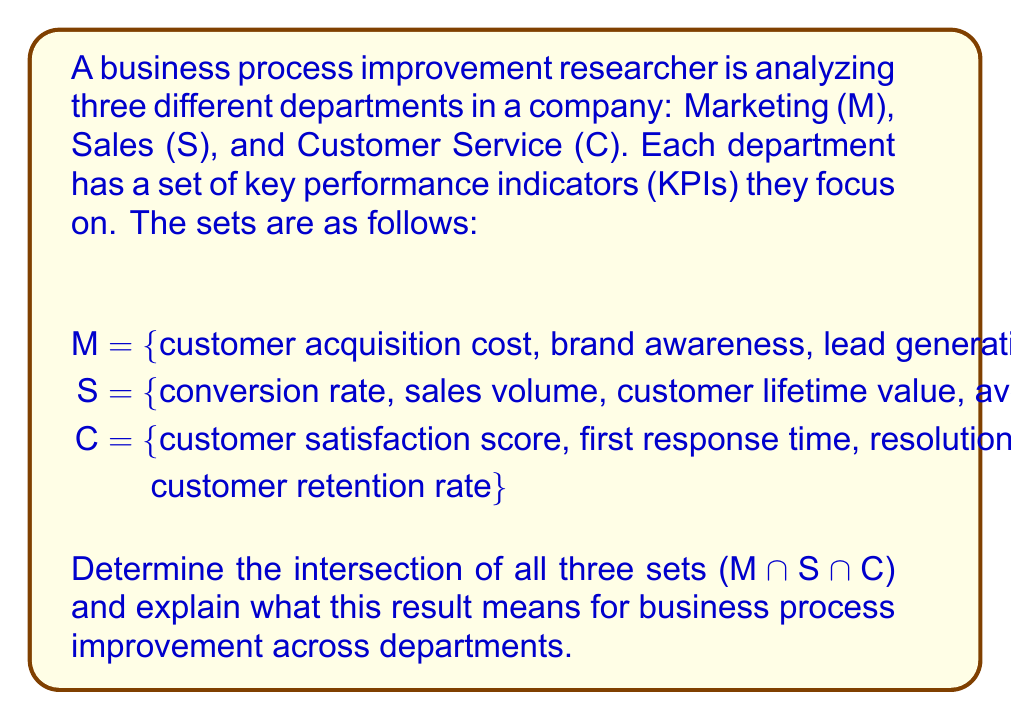Show me your answer to this math problem. To solve this problem, we need to identify the elements that are common to all three sets. Let's approach this step-by-step:

1. First, let's examine the elements in each set:
   M = {customer acquisition cost, brand awareness, lead generation, conversion rate}
   S = {conversion rate, sales volume, customer lifetime value, average deal size}
   C = {customer satisfaction score, first response time, resolution time, customer retention rate}

2. To find the intersection of all three sets, we need to identify elements that appear in all sets simultaneously.

3. Comparing the sets:
   - The only element that appears in more than one set is "conversion rate", which is present in both M and S.
   - However, "conversion rate" does not appear in set C.

4. Therefore, there are no elements that are common to all three sets.

5. Mathematically, we can express this as:
   $$ M ∩ S ∩ C = ∅ $$
   Where ∅ represents the empty set.

6. In terms of business process improvement, this result indicates that there are no KPIs that are currently shared across all three departments. This insight suggests several potential areas for improvement:

   a) The departments may be working in silos, with little integration of their performance metrics.
   b) There might be an opportunity to introduce cross-departmental KPIs that could foster better alignment and collaboration.
   c) The business could consider implementing a balanced scorecard approach that includes metrics relevant to all departments.

7. While "conversion rate" is shared between Marketing and Sales, there's an opportunity to extend this or introduce new metrics that also involve Customer Service, creating a more holistic view of the customer journey and business performance.
Answer: $$ M ∩ S ∩ C = ∅ $$ (empty set) 